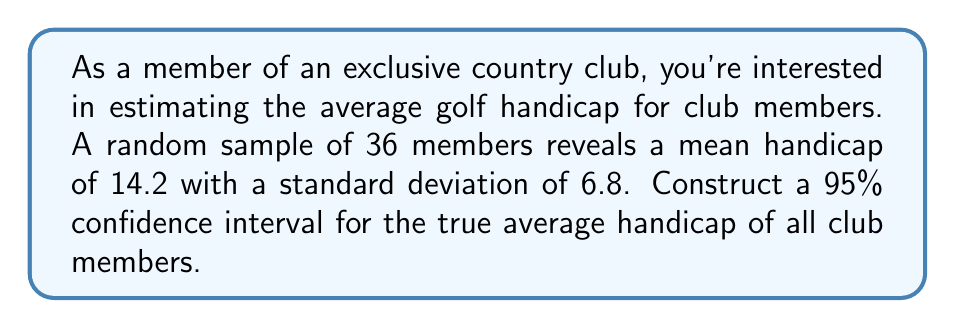Can you answer this question? To construct a 95% confidence interval, we'll follow these steps:

1) The formula for a confidence interval is:

   $$\bar{x} \pm t_{\alpha/2} \cdot \frac{s}{\sqrt{n}}$$

   where $\bar{x}$ is the sample mean, $s$ is the sample standard deviation, $n$ is the sample size, and $t_{\alpha/2}$ is the t-value for a 95% confidence level with $n-1$ degrees of freedom.

2) We have:
   $\bar{x} = 14.2$
   $s = 6.8$
   $n = 36$
   
3) For a 95% confidence level with 35 degrees of freedom, $t_{\alpha/2} \approx 2.030$ (from t-distribution table)

4) Plugging these values into our formula:

   $$14.2 \pm 2.030 \cdot \frac{6.8}{\sqrt{36}}$$

5) Simplify:
   $$14.2 \pm 2.030 \cdot \frac{6.8}{6} = 14.2 \pm 2.030 \cdot 1.133 = 14.2 \pm 2.30$$

6) Therefore, our confidence interval is:

   $$(14.2 - 2.30, 14.2 + 2.30) = (11.90, 16.50)$$
Answer: (11.90, 16.50) 